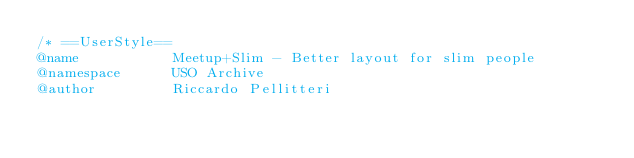Convert code to text. <code><loc_0><loc_0><loc_500><loc_500><_CSS_>/* ==UserStyle==
@name           Meetup+Slim - Better layout for slim people
@namespace      USO Archive
@author         Riccardo Pellitteri</code> 